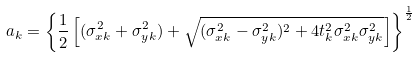Convert formula to latex. <formula><loc_0><loc_0><loc_500><loc_500>a _ { k } = \left \{ \frac { 1 } { 2 } \left [ ( \sigma ^ { 2 } _ { x k } + \sigma ^ { 2 } _ { y k } ) + \sqrt { ( \sigma ^ { 2 } _ { x k } - \sigma ^ { 2 } _ { y k } ) ^ { 2 } + 4 t _ { k } ^ { 2 } \sigma ^ { 2 } _ { x k } \sigma ^ { 2 } _ { y k } } \right ] \right \} ^ { \frac { 1 } { 2 } }</formula> 